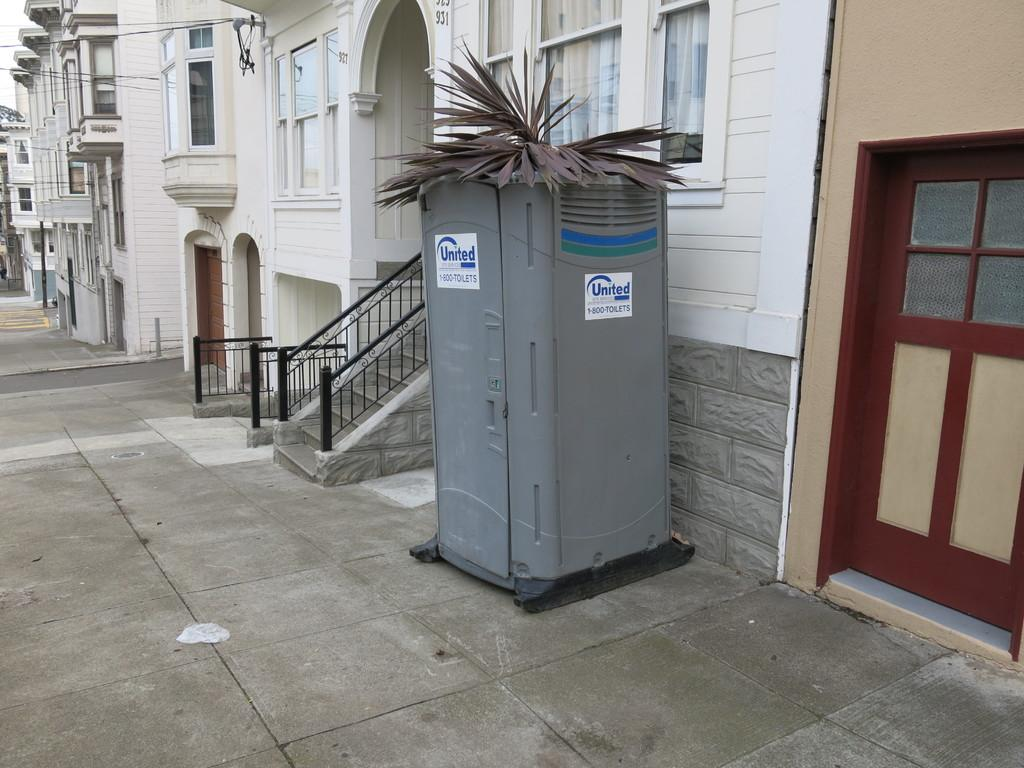What type of structures can be seen in the image? There are buildings in the image. What is the purpose of the fence in the image? The purpose of the fence is not explicitly stated, but it could be used for separating or enclosing areas. What is the box in the image used for? The purpose of the box is not explicitly stated, but it could be used for storage or transportation. How many doors are visible in the image? There are doors in the image, but the exact number is not specified. What else can be seen in the image besides buildings, a fence, a box, and doors? There are other objects in the image, but their specific nature is not mentioned. What is the purpose of the wires in the background of the image? The wires in the background of the image are likely used for transmitting electricity or communication signals. How does the wall in the image help to alleviate the pain of the people in the image? There is no wall present in the image, and therefore no such pain relief can be observed. What type of ship can be seen sailing in the background of the image? There is no ship present in the image; it features buildings, a fence, a box, doors, and wires. 